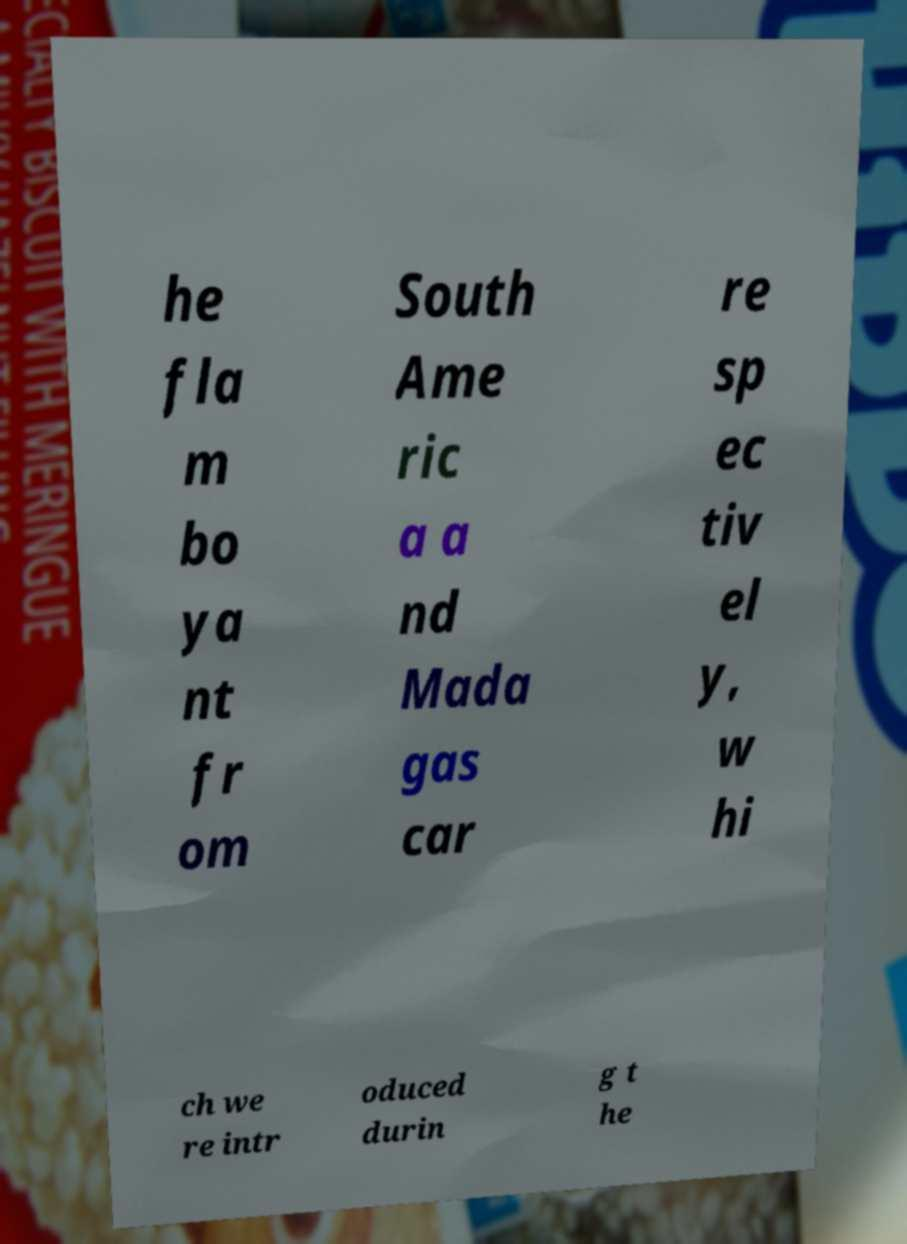For documentation purposes, I need the text within this image transcribed. Could you provide that? he fla m bo ya nt fr om South Ame ric a a nd Mada gas car re sp ec tiv el y, w hi ch we re intr oduced durin g t he 